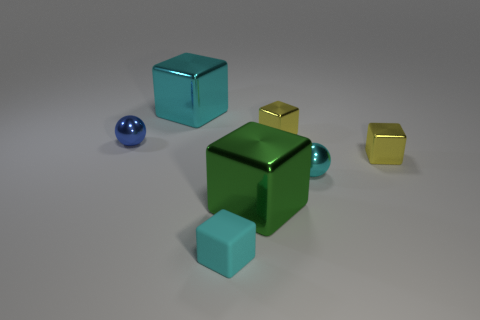Subtract all big green shiny cubes. How many cubes are left? 4 Subtract all green cubes. How many cubes are left? 4 Subtract all purple blocks. Subtract all blue spheres. How many blocks are left? 5 Add 2 large brown metallic objects. How many objects exist? 9 Subtract all spheres. How many objects are left? 5 Add 5 matte things. How many matte things exist? 6 Subtract 0 purple balls. How many objects are left? 7 Subtract all green metallic objects. Subtract all gray blocks. How many objects are left? 6 Add 1 large metal cubes. How many large metal cubes are left? 3 